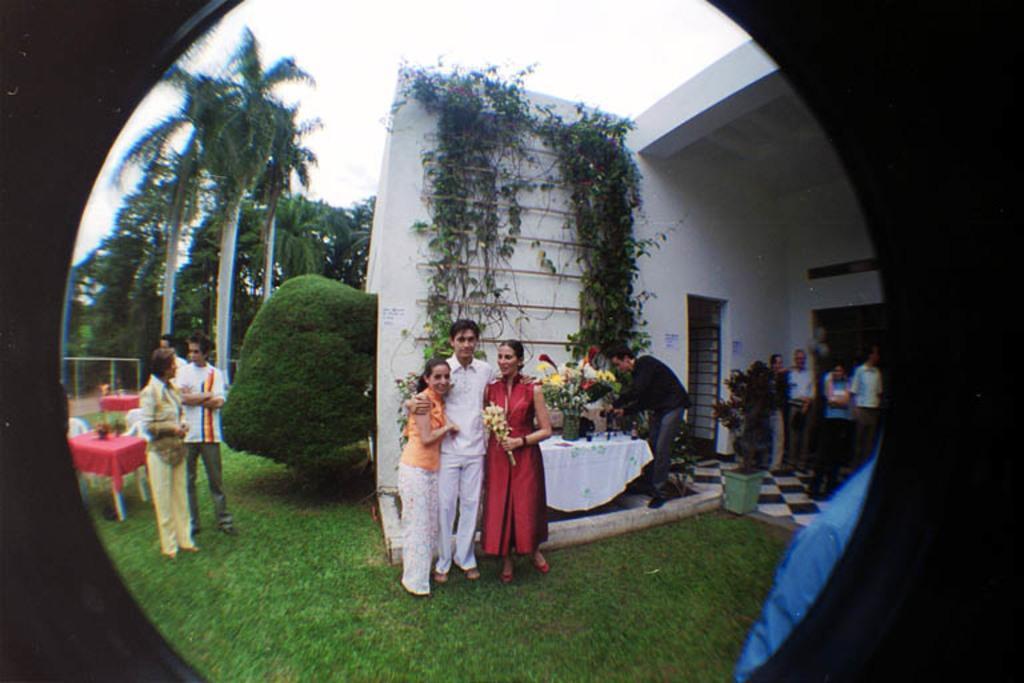Could you give a brief overview of what you see in this image? In this image I can see three persons standing, the person at right wearing red color dress, the person in middle wearing white dress and the person at left wearing orange shirt, white pant. Background I can see few other persons standing, trees in green color and sky in white color. 